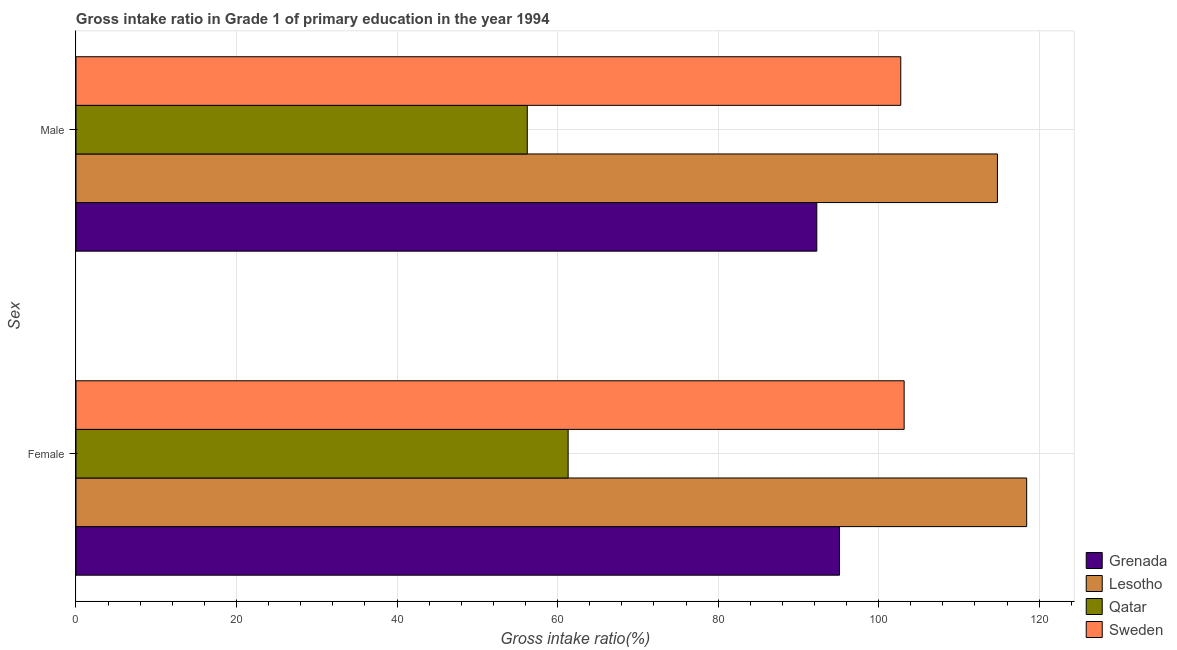How many different coloured bars are there?
Provide a succinct answer. 4. Are the number of bars per tick equal to the number of legend labels?
Your answer should be compact. Yes. What is the gross intake ratio(female) in Qatar?
Ensure brevity in your answer.  61.32. Across all countries, what is the maximum gross intake ratio(female)?
Provide a short and direct response. 118.44. Across all countries, what is the minimum gross intake ratio(female)?
Your response must be concise. 61.32. In which country was the gross intake ratio(male) maximum?
Your answer should be compact. Lesotho. In which country was the gross intake ratio(female) minimum?
Ensure brevity in your answer.  Qatar. What is the total gross intake ratio(female) in the graph?
Your answer should be very brief. 378.07. What is the difference between the gross intake ratio(male) in Sweden and that in Grenada?
Your response must be concise. 10.46. What is the difference between the gross intake ratio(male) in Qatar and the gross intake ratio(female) in Grenada?
Provide a short and direct response. -38.9. What is the average gross intake ratio(female) per country?
Your response must be concise. 94.52. What is the difference between the gross intake ratio(male) and gross intake ratio(female) in Lesotho?
Make the answer very short. -3.64. What is the ratio of the gross intake ratio(male) in Grenada to that in Qatar?
Your answer should be compact. 1.64. What does the 2nd bar from the top in Female represents?
Provide a succinct answer. Qatar. How many bars are there?
Your answer should be compact. 8. Does the graph contain any zero values?
Make the answer very short. No. Does the graph contain grids?
Provide a succinct answer. Yes. Where does the legend appear in the graph?
Provide a short and direct response. Bottom right. How are the legend labels stacked?
Your answer should be compact. Vertical. What is the title of the graph?
Make the answer very short. Gross intake ratio in Grade 1 of primary education in the year 1994. Does "Botswana" appear as one of the legend labels in the graph?
Your answer should be compact. No. What is the label or title of the X-axis?
Ensure brevity in your answer.  Gross intake ratio(%). What is the label or title of the Y-axis?
Provide a short and direct response. Sex. What is the Gross intake ratio(%) in Grenada in Female?
Keep it short and to the point. 95.13. What is the Gross intake ratio(%) of Lesotho in Female?
Your response must be concise. 118.44. What is the Gross intake ratio(%) of Qatar in Female?
Your response must be concise. 61.32. What is the Gross intake ratio(%) in Sweden in Female?
Ensure brevity in your answer.  103.18. What is the Gross intake ratio(%) in Grenada in Male?
Ensure brevity in your answer.  92.3. What is the Gross intake ratio(%) of Lesotho in Male?
Offer a terse response. 114.8. What is the Gross intake ratio(%) of Qatar in Male?
Your response must be concise. 56.23. What is the Gross intake ratio(%) of Sweden in Male?
Offer a very short reply. 102.76. Across all Sex, what is the maximum Gross intake ratio(%) in Grenada?
Make the answer very short. 95.13. Across all Sex, what is the maximum Gross intake ratio(%) of Lesotho?
Make the answer very short. 118.44. Across all Sex, what is the maximum Gross intake ratio(%) in Qatar?
Keep it short and to the point. 61.32. Across all Sex, what is the maximum Gross intake ratio(%) of Sweden?
Your answer should be very brief. 103.18. Across all Sex, what is the minimum Gross intake ratio(%) of Grenada?
Offer a terse response. 92.3. Across all Sex, what is the minimum Gross intake ratio(%) of Lesotho?
Offer a terse response. 114.8. Across all Sex, what is the minimum Gross intake ratio(%) in Qatar?
Your response must be concise. 56.23. Across all Sex, what is the minimum Gross intake ratio(%) in Sweden?
Your answer should be compact. 102.76. What is the total Gross intake ratio(%) of Grenada in the graph?
Your answer should be compact. 187.42. What is the total Gross intake ratio(%) of Lesotho in the graph?
Provide a short and direct response. 233.25. What is the total Gross intake ratio(%) in Qatar in the graph?
Make the answer very short. 117.54. What is the total Gross intake ratio(%) of Sweden in the graph?
Make the answer very short. 205.93. What is the difference between the Gross intake ratio(%) in Grenada in Female and that in Male?
Your response must be concise. 2.83. What is the difference between the Gross intake ratio(%) in Lesotho in Female and that in Male?
Provide a succinct answer. 3.64. What is the difference between the Gross intake ratio(%) in Qatar in Female and that in Male?
Keep it short and to the point. 5.09. What is the difference between the Gross intake ratio(%) of Sweden in Female and that in Male?
Your answer should be compact. 0.42. What is the difference between the Gross intake ratio(%) of Grenada in Female and the Gross intake ratio(%) of Lesotho in Male?
Ensure brevity in your answer.  -19.67. What is the difference between the Gross intake ratio(%) of Grenada in Female and the Gross intake ratio(%) of Qatar in Male?
Offer a terse response. 38.9. What is the difference between the Gross intake ratio(%) of Grenada in Female and the Gross intake ratio(%) of Sweden in Male?
Make the answer very short. -7.63. What is the difference between the Gross intake ratio(%) of Lesotho in Female and the Gross intake ratio(%) of Qatar in Male?
Provide a succinct answer. 62.22. What is the difference between the Gross intake ratio(%) in Lesotho in Female and the Gross intake ratio(%) in Sweden in Male?
Make the answer very short. 15.69. What is the difference between the Gross intake ratio(%) of Qatar in Female and the Gross intake ratio(%) of Sweden in Male?
Ensure brevity in your answer.  -41.44. What is the average Gross intake ratio(%) in Grenada per Sex?
Keep it short and to the point. 93.71. What is the average Gross intake ratio(%) of Lesotho per Sex?
Ensure brevity in your answer.  116.62. What is the average Gross intake ratio(%) of Qatar per Sex?
Your answer should be compact. 58.77. What is the average Gross intake ratio(%) of Sweden per Sex?
Offer a very short reply. 102.97. What is the difference between the Gross intake ratio(%) in Grenada and Gross intake ratio(%) in Lesotho in Female?
Your answer should be very brief. -23.32. What is the difference between the Gross intake ratio(%) of Grenada and Gross intake ratio(%) of Qatar in Female?
Your response must be concise. 33.81. What is the difference between the Gross intake ratio(%) of Grenada and Gross intake ratio(%) of Sweden in Female?
Give a very brief answer. -8.05. What is the difference between the Gross intake ratio(%) of Lesotho and Gross intake ratio(%) of Qatar in Female?
Ensure brevity in your answer.  57.13. What is the difference between the Gross intake ratio(%) of Lesotho and Gross intake ratio(%) of Sweden in Female?
Provide a short and direct response. 15.27. What is the difference between the Gross intake ratio(%) in Qatar and Gross intake ratio(%) in Sweden in Female?
Offer a terse response. -41.86. What is the difference between the Gross intake ratio(%) in Grenada and Gross intake ratio(%) in Lesotho in Male?
Give a very brief answer. -22.5. What is the difference between the Gross intake ratio(%) of Grenada and Gross intake ratio(%) of Qatar in Male?
Your response must be concise. 36.07. What is the difference between the Gross intake ratio(%) of Grenada and Gross intake ratio(%) of Sweden in Male?
Your answer should be very brief. -10.46. What is the difference between the Gross intake ratio(%) of Lesotho and Gross intake ratio(%) of Qatar in Male?
Make the answer very short. 58.58. What is the difference between the Gross intake ratio(%) of Lesotho and Gross intake ratio(%) of Sweden in Male?
Your response must be concise. 12.04. What is the difference between the Gross intake ratio(%) in Qatar and Gross intake ratio(%) in Sweden in Male?
Your response must be concise. -46.53. What is the ratio of the Gross intake ratio(%) in Grenada in Female to that in Male?
Offer a very short reply. 1.03. What is the ratio of the Gross intake ratio(%) of Lesotho in Female to that in Male?
Your response must be concise. 1.03. What is the ratio of the Gross intake ratio(%) in Qatar in Female to that in Male?
Your answer should be very brief. 1.09. What is the difference between the highest and the second highest Gross intake ratio(%) of Grenada?
Your answer should be very brief. 2.83. What is the difference between the highest and the second highest Gross intake ratio(%) in Lesotho?
Your answer should be compact. 3.64. What is the difference between the highest and the second highest Gross intake ratio(%) of Qatar?
Provide a succinct answer. 5.09. What is the difference between the highest and the second highest Gross intake ratio(%) in Sweden?
Give a very brief answer. 0.42. What is the difference between the highest and the lowest Gross intake ratio(%) in Grenada?
Your answer should be compact. 2.83. What is the difference between the highest and the lowest Gross intake ratio(%) in Lesotho?
Offer a terse response. 3.64. What is the difference between the highest and the lowest Gross intake ratio(%) of Qatar?
Your response must be concise. 5.09. What is the difference between the highest and the lowest Gross intake ratio(%) of Sweden?
Your answer should be compact. 0.42. 